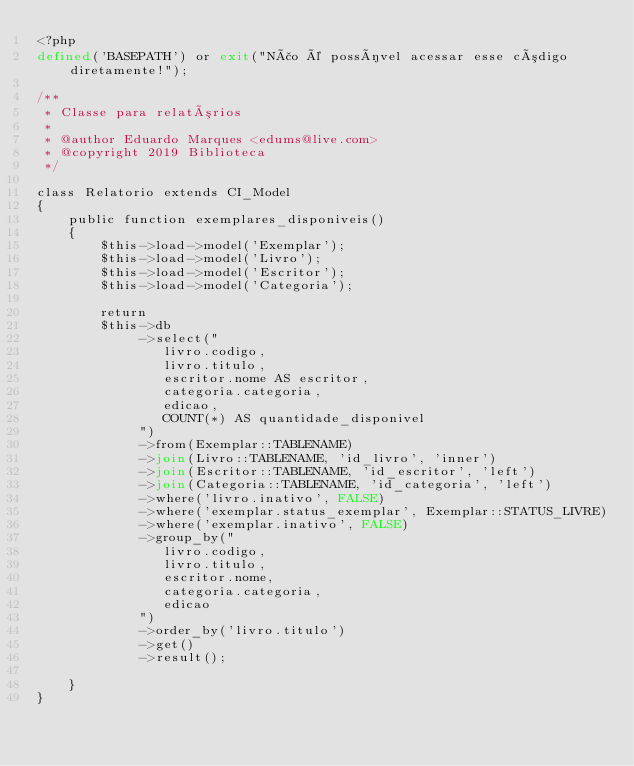Convert code to text. <code><loc_0><loc_0><loc_500><loc_500><_PHP_><?php
defined('BASEPATH') or exit("Não é possível acessar esse código diretamente!");

/**
 * Classe para relatórios
 * 
 * @author Eduardo Marques <edums@live.com>
 * @copyright 2019 Biblioteca
 */

class Relatorio extends CI_Model
{
    public function exemplares_disponiveis()
    {
        $this->load->model('Exemplar');
        $this->load->model('Livro');
        $this->load->model('Escritor');
        $this->load->model('Categoria');

        return 
        $this->db
             ->select("
                livro.codigo,
                livro.titulo,
                escritor.nome AS escritor,
                categoria.categoria,
                edicao,
                COUNT(*) AS quantidade_disponivel
             ")
             ->from(Exemplar::TABLENAME)
             ->join(Livro::TABLENAME, 'id_livro', 'inner')
             ->join(Escritor::TABLENAME, 'id_escritor', 'left')
             ->join(Categoria::TABLENAME, 'id_categoria', 'left')
             ->where('livro.inativo', FALSE)
             ->where('exemplar.status_exemplar', Exemplar::STATUS_LIVRE)
             ->where('exemplar.inativo', FALSE)
             ->group_by("
                livro.codigo,
                livro.titulo,
                escritor.nome,
                categoria.categoria,
                edicao
             ")
             ->order_by('livro.titulo')
             ->get()
             ->result();

    }
}</code> 